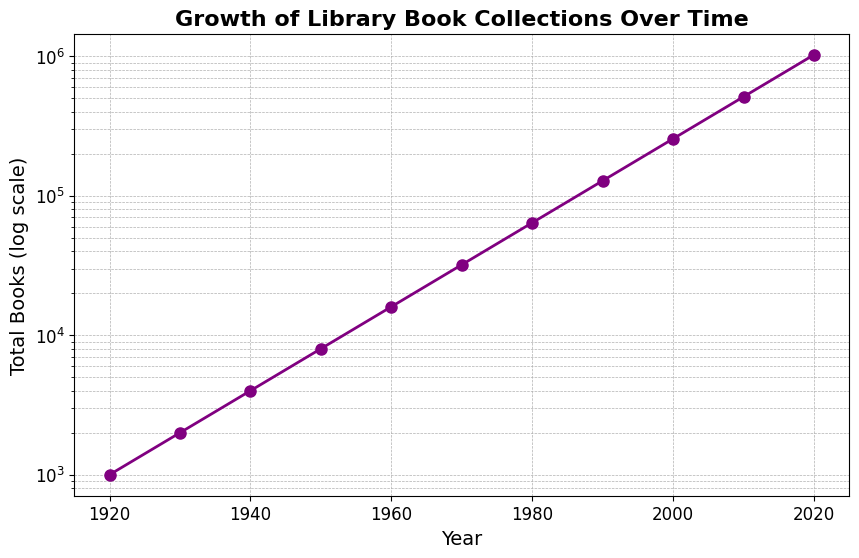What's the rate of growth in total books between 1950 and 2000? The total books in 1950 are 8,000, and in 2000 are 256,000. To find the rate of growth, we use the formula (final value - initial value) / initial value. So, (256,000 - 8,000) / 8,000 = 248,000 / 8,000 = 31 times growth.
Answer: 31 times How many times did the collection grow between 1960 and 2020? In 1960, there were 16,000 books, and in 2020, there were 1,024,000 books. The rate of growth is (1,024,000 / 16,000) = 64 times.
Answer: 64 times Which decade saw the smaller growth in the number of books: 1930s or 1950s? Growth in the 1930s is (4,000 - 2,000) / 2,000 = 1. Growth in the 1950s is (16,000 - 8,000) / 8,000 = 1. Both decades saw the same growth rate of 1 or 100%.
Answer: Same growth rate What is the general trend in the growth of book collections over time? The general trend shows an exponential growth in total books over time.
Answer: Exponential growth How did the number of books change from 1990 to 2020? The number of books in 1990 was 128,000 and in 2020 was 1,024,000. The total increase is (1,024,000 - 128,000) = 896,000.
Answer: Increased by 896,000 Between which consecutive years does the collection double for the first time? Starting with 1,000 books in 1920, the collection doubles approximately every 10 years initially. The first doubling occurs between 1920 and 1930.
Answer: 1920 to 1930 In which year does the total number of books surpass 100,000? The collection exceeds 100,000 books in the year 1990.
Answer: 1990 By how much did the collection increase between 2000 and 2010? The number of books in 2000 was 256,000, and in 2010 it was 512,000. The increase is (512,000 - 256,000) = 256,000.
Answer: 256,000 What can you infer about the collection size in 1935? Based on the exponential growth pattern, we can infer the collection size in 1935 to be approximately halfway between 2000 in 1930 and 4000 in 1940, which is around 2800.
Answer: Approximately 2800 